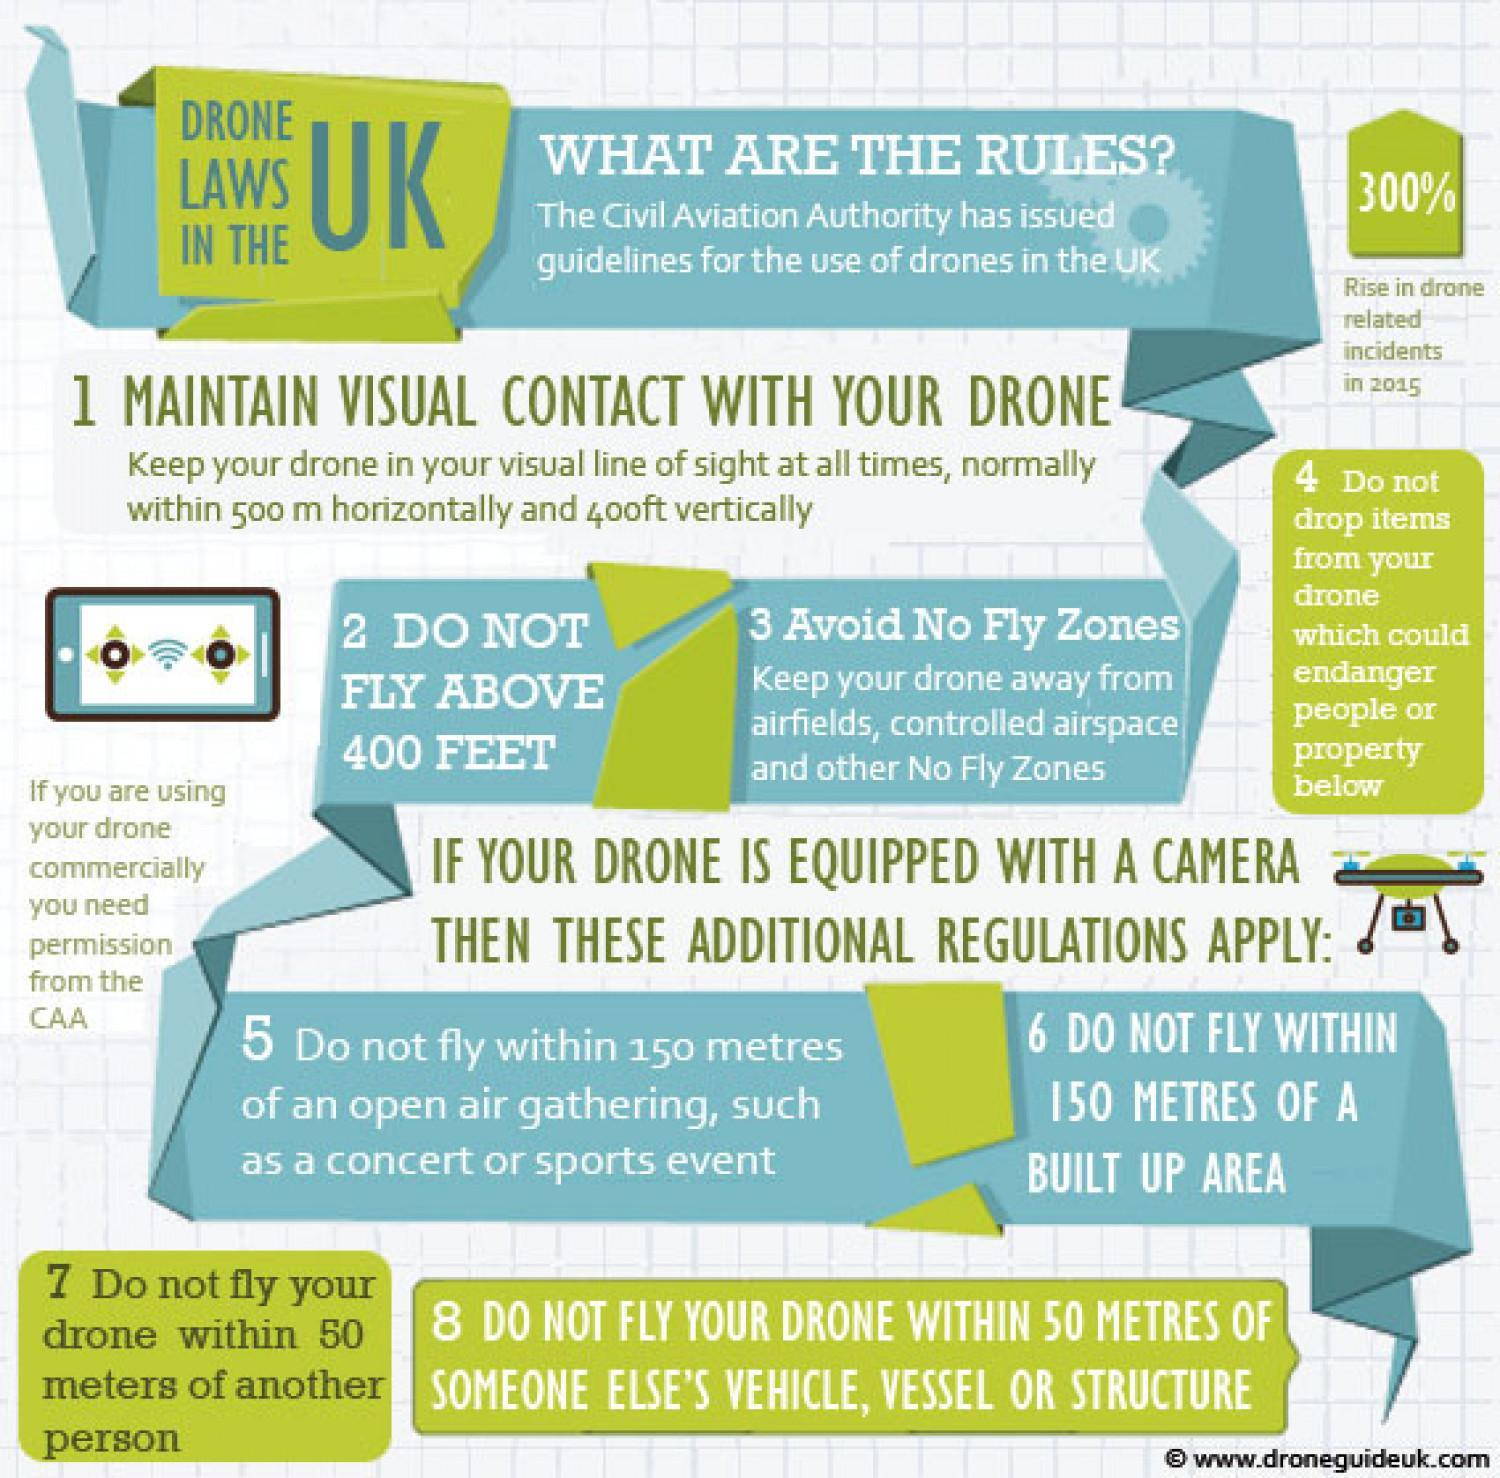What is the percentage rise in drone related incidents in UK in 2015?
Answer the question with a short phrase. 300% Which authority permission is required for using the drones in UK? CAA 